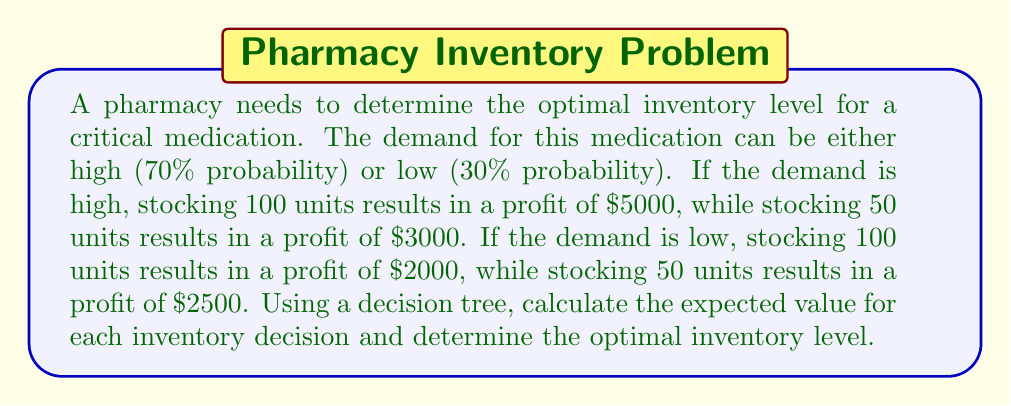Give your solution to this math problem. Let's approach this problem using a decision tree:

1. First, we'll create a decision tree with two main branches: stocking 100 units and stocking 50 units.

2. For each of these decisions, we'll have two sub-branches representing high and low demand.

3. We'll calculate the expected value (EV) for each decision:

   For stocking 100 units:
   $$ EV_{100} = (0.7 \times 5000) + (0.3 \times 2000) = 3500 + 600 = 4100 $$

   For stocking 50 units:
   $$ EV_{50} = (0.7 \times 3000) + (0.3 \times 2500) = 2100 + 750 = 2850 $$

4. The decision tree can be represented as follows:

   [asy]
   import geometry;

   size(300,200);

   pair A=(0,0), B=(100,50), C=(100,-50), D=(200,75), E=(200,25), F=(200,-25), G=(200,-75);

   draw(A--B--D);
   draw(B--E);
   draw(A--C--F);
   draw(C--G);

   label("Stock", A, W);
   label("100", B, E);
   label("50", C, E);
   label("High (70%): $5000", D, E);
   label("Low (30%): $2000", E, E);
   label("High (70%): $3000", F, E);
   label("Low (30%): $2500", G, E);

   dot(A);
   dot(B);
   dot(C);
   [/asy]

5. Compare the expected values:
   $EV_{100} = 4100 > EV_{50} = 2850$

Therefore, the optimal decision is to stock 100 units, as it provides a higher expected value.
Answer: The optimal inventory level is 100 units, with an expected value of $4100. 